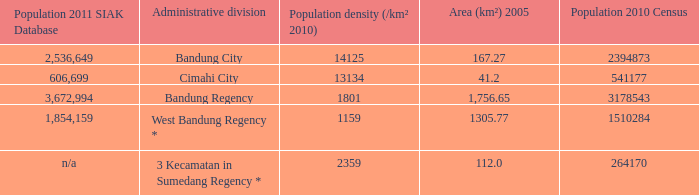Help me parse the entirety of this table. {'header': ['Population 2011 SIAK Database', 'Administrative division', 'Population density (/km² 2010)', 'Area (km²) 2005', 'Population 2010 Census'], 'rows': [['2,536,649', 'Bandung City', '14125', '167.27', '2394873'], ['606,699', 'Cimahi City', '13134', '41.2', '541177'], ['3,672,994', 'Bandung Regency', '1801', '1,756.65', '3178543'], ['1,854,159', 'West Bandung Regency *', '1159', '1305.77', '1510284'], ['n/a', '3 Kecamatan in Sumedang Regency *', '2359', '112.0', '264170']]} What is the population density of the administrative division with a population in 2010 of 264170 according to the census? 2359.0. 